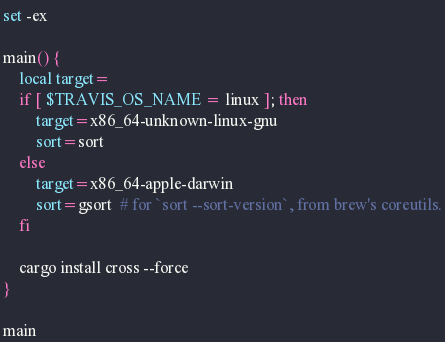<code> <loc_0><loc_0><loc_500><loc_500><_Bash_>set -ex

main() {
    local target=
    if [ $TRAVIS_OS_NAME = linux ]; then
        target=x86_64-unknown-linux-gnu
        sort=sort
    else
        target=x86_64-apple-darwin
        sort=gsort  # for `sort --sort-version`, from brew's coreutils.
    fi

    cargo install cross --force
}

main
</code> 